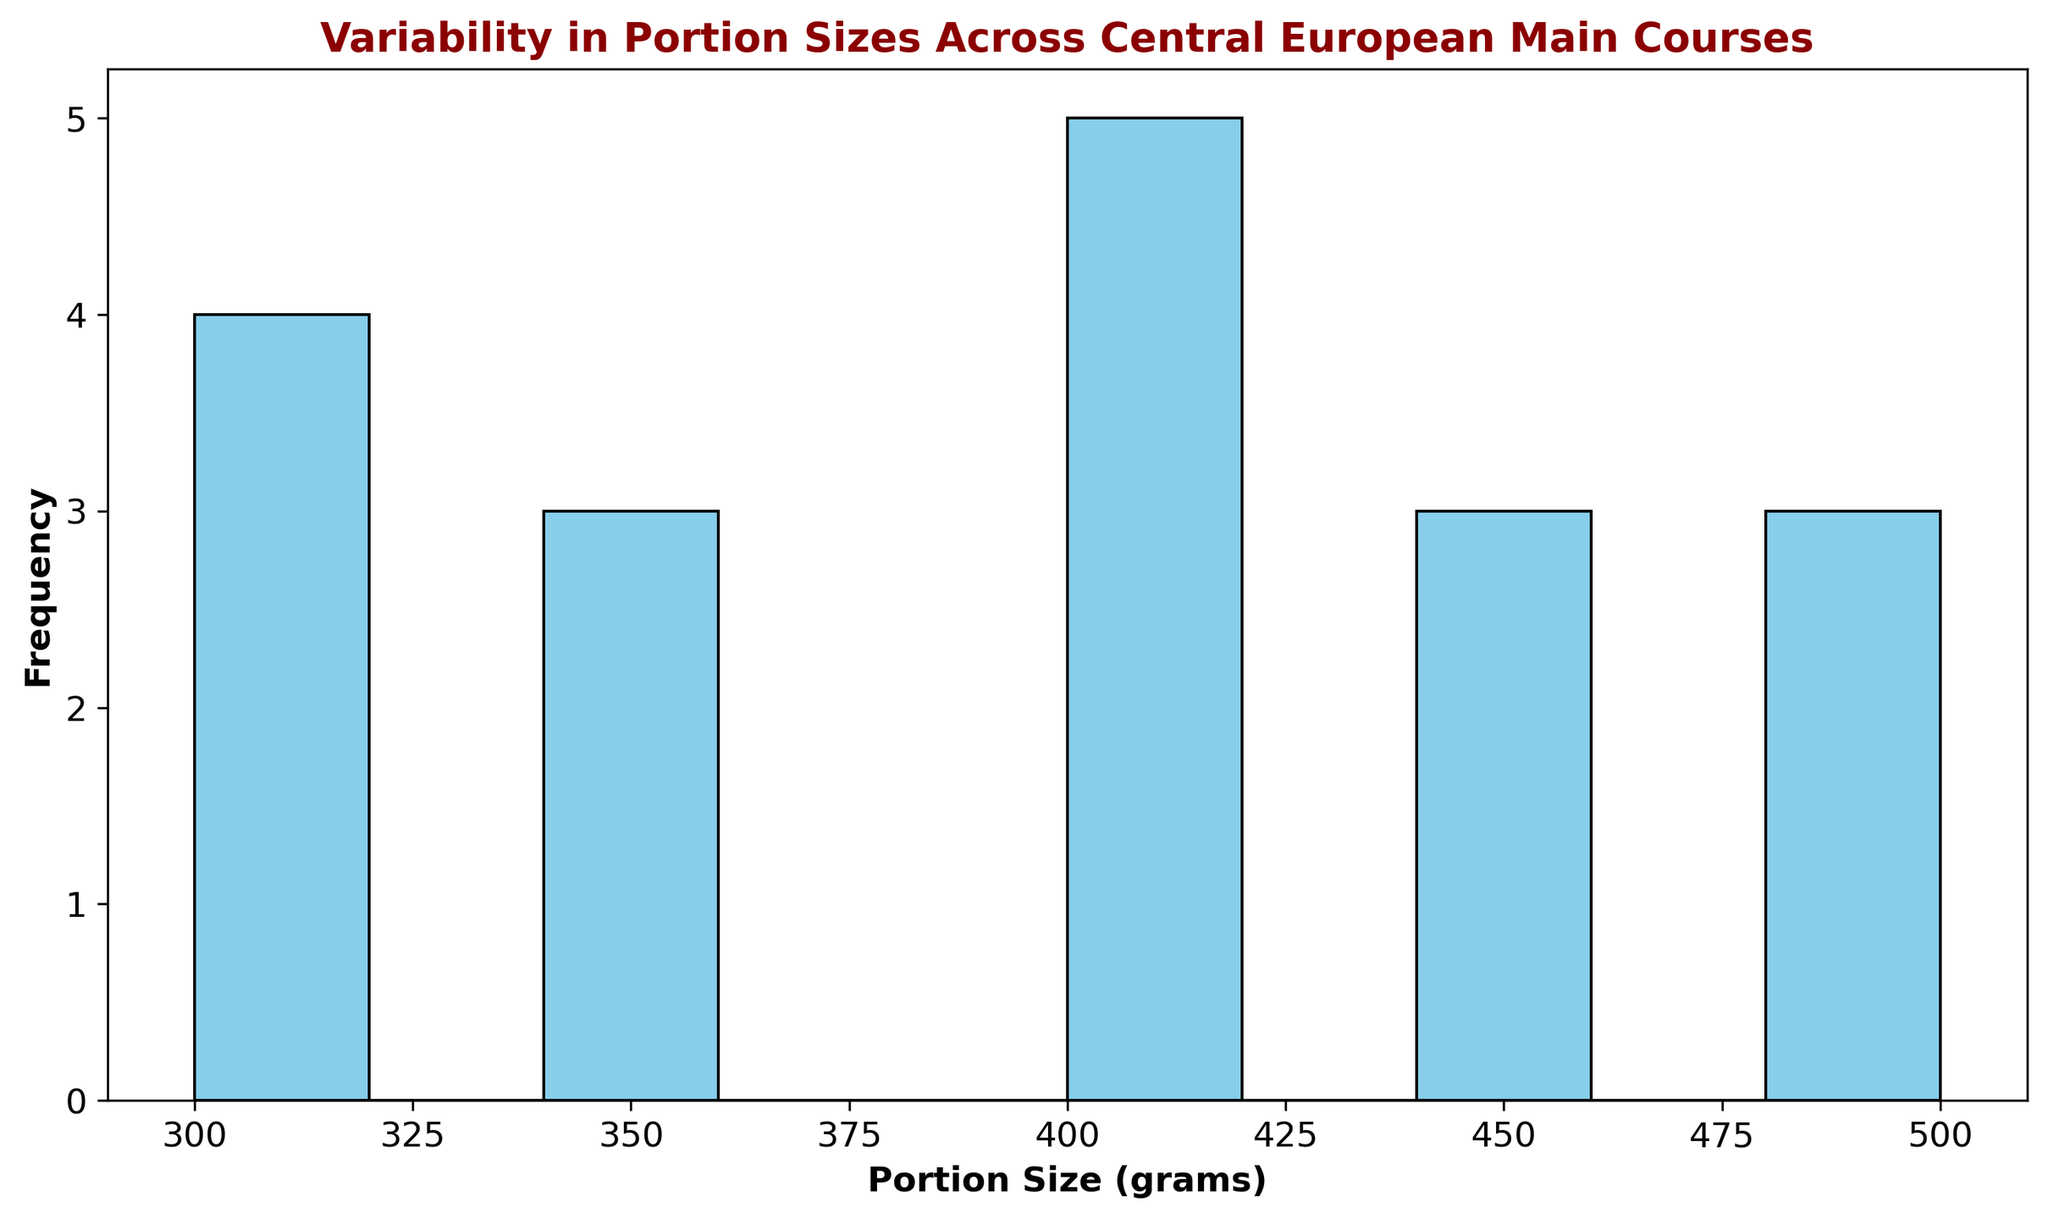What is the range of portion sizes depicted in the histogram? To calculate the range, look at the smallest and largest bins. The smallest bin starts at 300 grams and the largest ends at 500 grams. Thus, the range is from 300 to 500 grams.
Answer: 300-500 grams Which portion size range appears most frequently? Look for the tallest bar in the histogram. The highest bar is in the bins from 300 to 350 grams. This is the most frequent portion size range.
Answer: 300-350 grams How many dishes have portion sizes between 400 and 450 grams? Identify the bar corresponding to the range of 400-450 grams and count its height. The bar’s height indicates it covers 5 dishes.
Answer: 5 dishes What is the sum of dishes with portion sizes between 300 and 350 grams and those with sizes between 450 and 500 grams? Count the heights of the bars for 300-350 grams and 450-500 grams. There are 4 dishes in 300-350 grams and 4 dishes in 450-500 grams, so 4 + 4 = 8 dishes.
Answer: 8 dishes Compare the frequency of dishes with portion sizes of 350-400 grams to those with 300-350 grams. Which one is higher? Look at the heights of the bars for 350-400 grams and 300-350 grams. The 300-350 grams bar is taller.
Answer: 300-350 grams What portion sizes have the least frequency, and how many dishes fall into these bins? Look for the shortest bars. The ranges 350-400 grams, 450-500 grams, and 300 grams each have the shortest bars with a height indicating 3 dishes each.
Answer: 350-400 g, 450-500 g, 300 g; each has 3 dishes Calculate the average number of dishes per bin. Find the total number of dishes by summing all bars. There are 15 dishes. The number of bins is 6. Thus, the average is 15 / 6 = 2.5 dishes per bin.
Answer: 2.5 dishes per bin Which bin represents dishes with a portion size strictly greater than 450 grams? Identify the bar that starts at 450 grams. The bin from 450-500 grams represents these dishes.
Answer: 450-500 grams Are there any bins that have an equal number of dishes? If so, which ones? Scan the histogram for bars of equal height. The bins from 400-450 grams and 500-550 grams both have 3 dishes.
Answer: 400-450 g, 500-550 g What portion size range has a frequency of dishes exactly equal to 3? Identify the bins with heights indicating 3 dishes. The bins are 350-400 grams and 450-500 grams.
Answer: 350-400 g, 450-500 g 